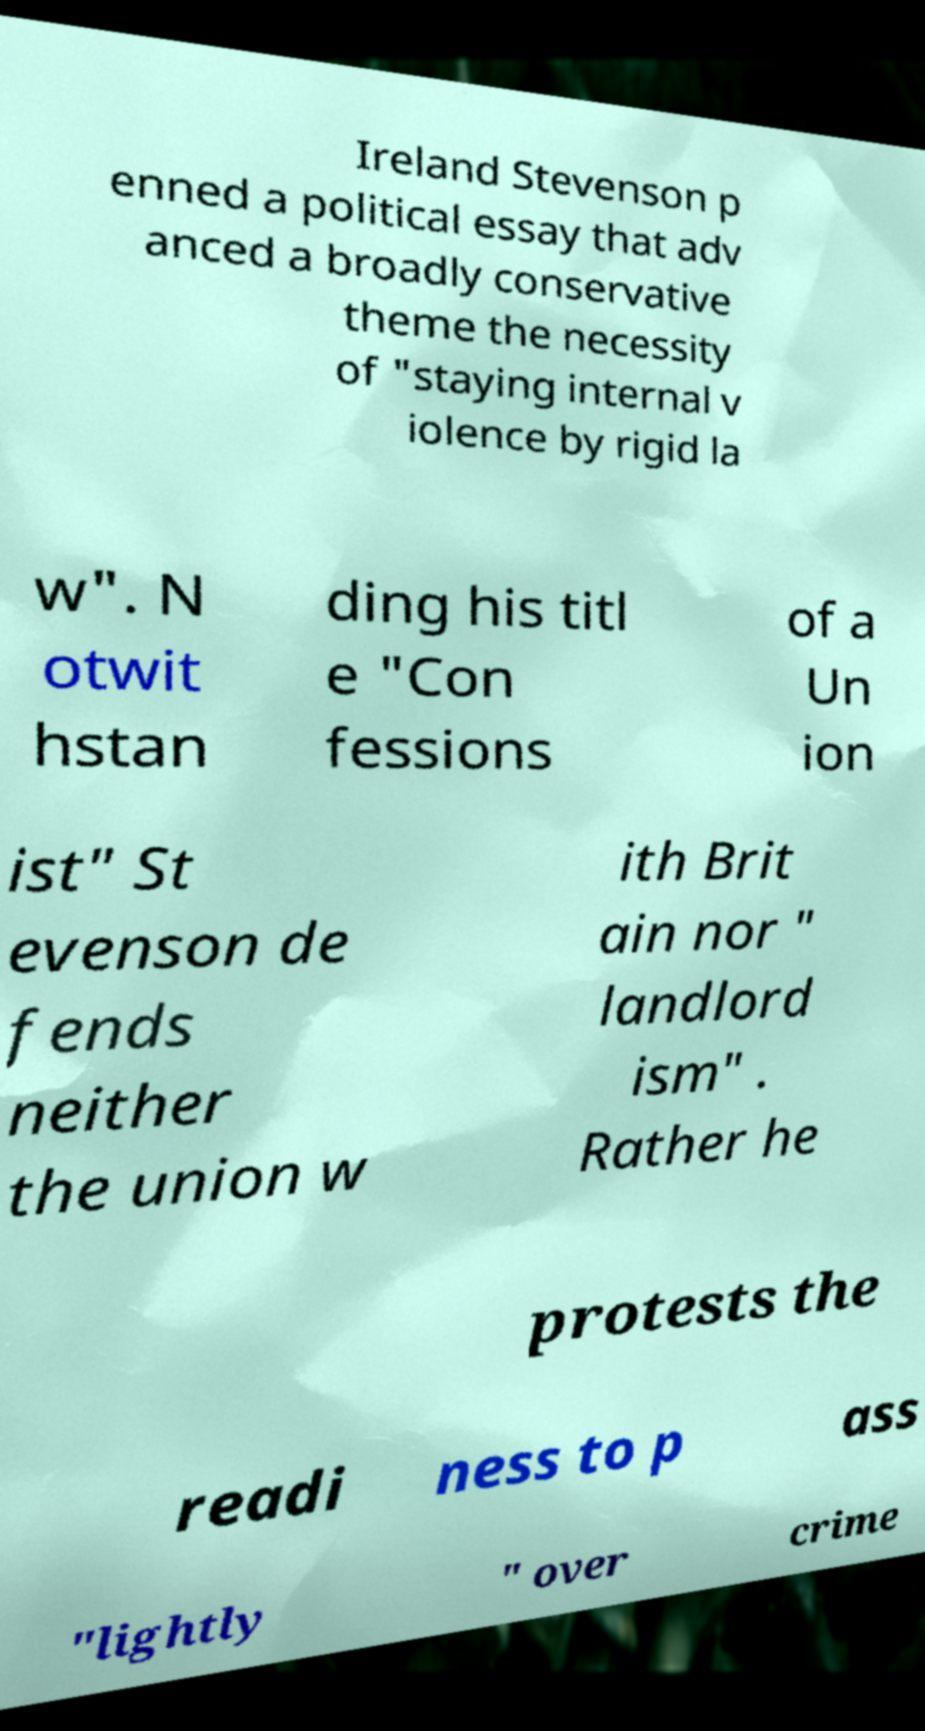Could you assist in decoding the text presented in this image and type it out clearly? Ireland Stevenson p enned a political essay that adv anced a broadly conservative theme the necessity of "staying internal v iolence by rigid la w". N otwit hstan ding his titl e "Con fessions of a Un ion ist" St evenson de fends neither the union w ith Brit ain nor " landlord ism" . Rather he protests the readi ness to p ass "lightly " over crime 